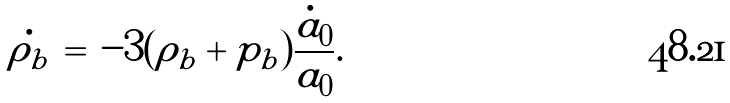<formula> <loc_0><loc_0><loc_500><loc_500>\dot { \rho _ { b } } \, = \, - 3 ( \rho _ { b } + p _ { b } ) \frac { \dot { a } _ { 0 } } { a _ { 0 } } .</formula> 